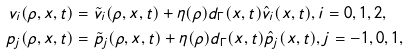Convert formula to latex. <formula><loc_0><loc_0><loc_500><loc_500>v _ { i } ( \rho , x , t ) & = \tilde { v } _ { i } ( \rho , x , t ) + \eta ( \rho ) d _ { \Gamma } ( x , t ) \hat { v } _ { i } ( x , t ) , i = 0 , 1 , 2 , \\ p _ { j } ( \rho , x , t ) & = \tilde { p } _ { j } ( \rho , x , t ) + \eta ( \rho ) d _ { \Gamma } ( x , t ) \hat { p } _ { j } ( x , t ) , j = - 1 , 0 , 1 ,</formula> 